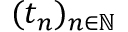Convert formula to latex. <formula><loc_0><loc_0><loc_500><loc_500>( t _ { n } ) _ { n \in \mathbb { N } }</formula> 